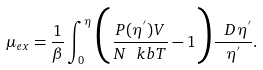<formula> <loc_0><loc_0><loc_500><loc_500>\mu _ { e x } = \frac { 1 } { \beta } \int _ { 0 } ^ { \eta } \Big { ( } \frac { P ( \eta ^ { ^ { \prime } } ) V } { N \ k b T } - 1 \Big { ) } \frac { \ D \eta ^ { ^ { \prime } } } { \eta ^ { ^ { \prime } } } .</formula> 